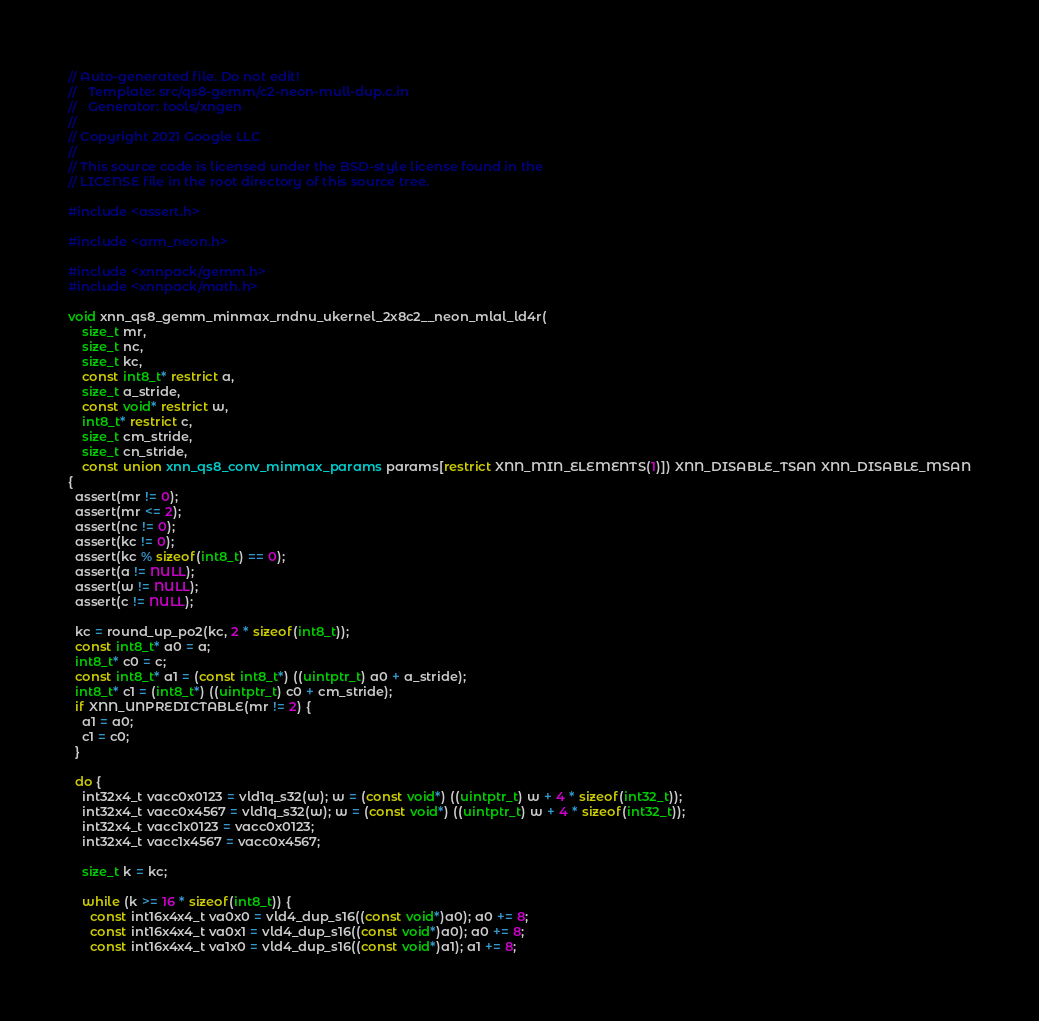<code> <loc_0><loc_0><loc_500><loc_500><_C_>// Auto-generated file. Do not edit!
//   Template: src/qs8-gemm/c2-neon-mull-dup.c.in
//   Generator: tools/xngen
//
// Copyright 2021 Google LLC
//
// This source code is licensed under the BSD-style license found in the
// LICENSE file in the root directory of this source tree.

#include <assert.h>

#include <arm_neon.h>

#include <xnnpack/gemm.h>
#include <xnnpack/math.h>

void xnn_qs8_gemm_minmax_rndnu_ukernel_2x8c2__neon_mlal_ld4r(
    size_t mr,
    size_t nc,
    size_t kc,
    const int8_t* restrict a,
    size_t a_stride,
    const void* restrict w,
    int8_t* restrict c,
    size_t cm_stride,
    size_t cn_stride,
    const union xnn_qs8_conv_minmax_params params[restrict XNN_MIN_ELEMENTS(1)]) XNN_DISABLE_TSAN XNN_DISABLE_MSAN
{
  assert(mr != 0);
  assert(mr <= 2);
  assert(nc != 0);
  assert(kc != 0);
  assert(kc % sizeof(int8_t) == 0);
  assert(a != NULL);
  assert(w != NULL);
  assert(c != NULL);

  kc = round_up_po2(kc, 2 * sizeof(int8_t));
  const int8_t* a0 = a;
  int8_t* c0 = c;
  const int8_t* a1 = (const int8_t*) ((uintptr_t) a0 + a_stride);
  int8_t* c1 = (int8_t*) ((uintptr_t) c0 + cm_stride);
  if XNN_UNPREDICTABLE(mr != 2) {
    a1 = a0;
    c1 = c0;
  }

  do {
    int32x4_t vacc0x0123 = vld1q_s32(w); w = (const void*) ((uintptr_t) w + 4 * sizeof(int32_t));
    int32x4_t vacc0x4567 = vld1q_s32(w); w = (const void*) ((uintptr_t) w + 4 * sizeof(int32_t));
    int32x4_t vacc1x0123 = vacc0x0123;
    int32x4_t vacc1x4567 = vacc0x4567;

    size_t k = kc;

    while (k >= 16 * sizeof(int8_t)) {
      const int16x4x4_t va0x0 = vld4_dup_s16((const void*)a0); a0 += 8;
      const int16x4x4_t va0x1 = vld4_dup_s16((const void*)a0); a0 += 8;
      const int16x4x4_t va1x0 = vld4_dup_s16((const void*)a1); a1 += 8;</code> 